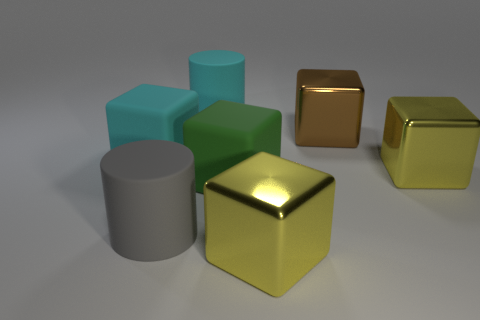What number of large yellow shiny cubes are there?
Provide a short and direct response. 2. There is a cube that is left of the large cylinder that is in front of the big yellow metal thing that is to the right of the big brown shiny cube; how big is it?
Your answer should be compact. Large. Are there any other things that have the same size as the gray cylinder?
Make the answer very short. Yes. There is a cyan matte block; what number of large things are on the left side of it?
Provide a short and direct response. 0. Are there an equal number of green cubes that are in front of the large cyan cylinder and big green metallic spheres?
Make the answer very short. No. How many things are big yellow shiny blocks or large cyan metallic cylinders?
Make the answer very short. 2. There is a big rubber thing on the right side of the rubber cylinder that is behind the big cyan rubber block; what shape is it?
Your response must be concise. Cube. There is a green object that is made of the same material as the cyan block; what shape is it?
Provide a short and direct response. Cube. What is the shape of the large gray rubber object?
Provide a succinct answer. Cylinder. How many large objects are purple rubber spheres or cyan matte cubes?
Give a very brief answer. 1. 